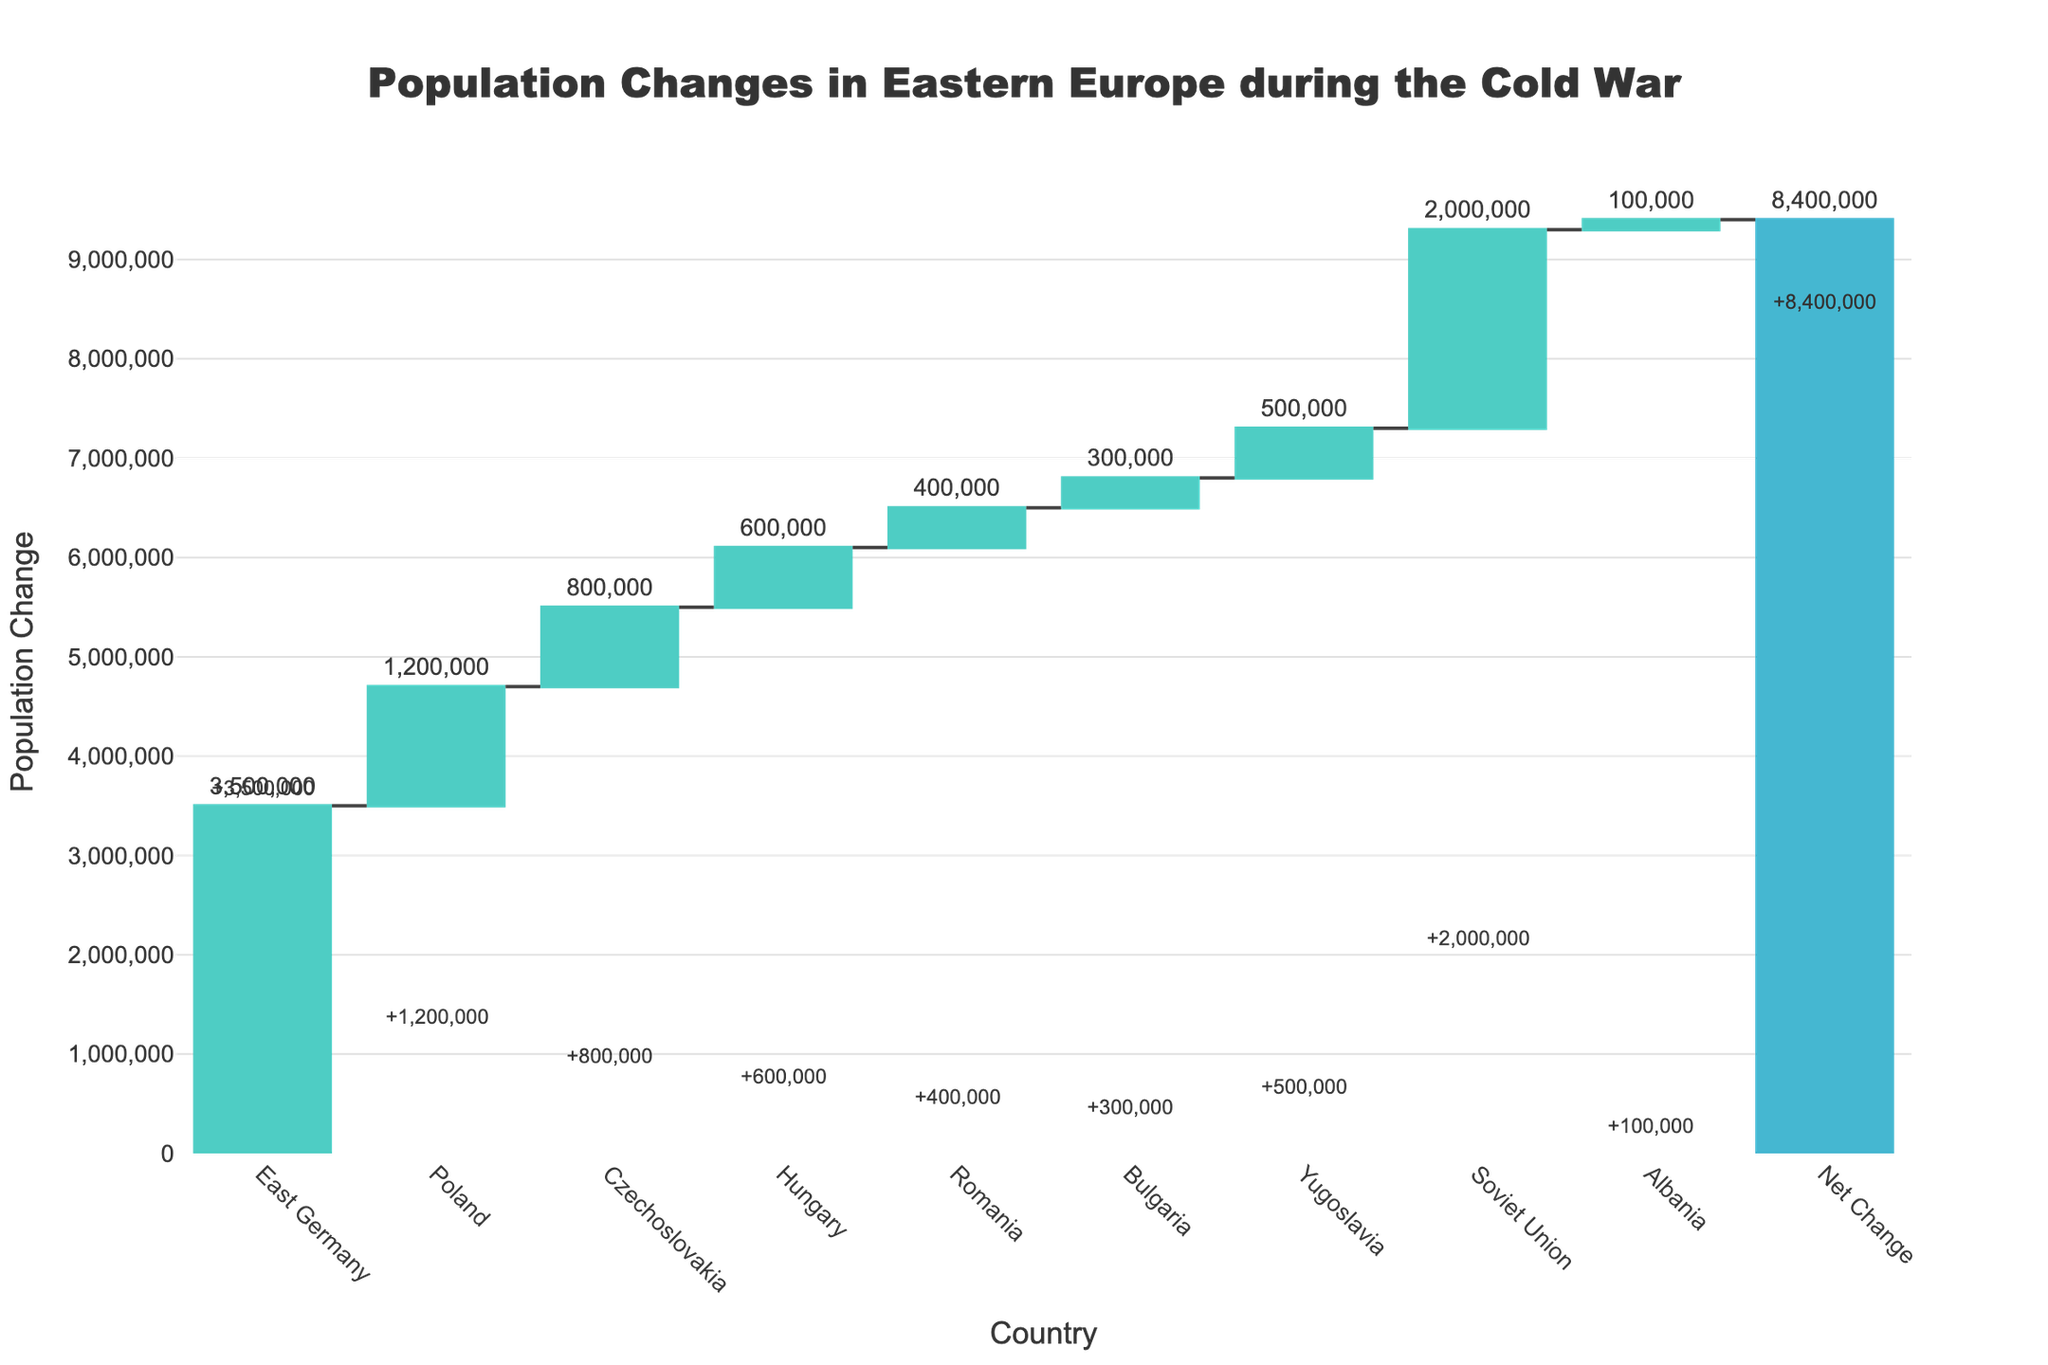What is the title of the chart? The title is located at the top of the chart and reads "Population Changes in Eastern Europe during the Cold War".
Answer: "Population Changes in Eastern Europe during the Cold War" Which country experienced the largest population decrease? Looking at the chart, the largest decline in population is represented by the bar for East Germany, which has the farthest downward extent.
Answer: East Germany What is the total net change in population? The net change in population is shown as the last bar in the chart, labeled "Net Change," which sums all the increases and decreases. It shows -8,400,000.
Answer: -8,400,000 How does the population change in Yugoslavia compare to other countries? Yugoslavia is the only country with an upward bar, indicating a population increase, while all other countries have downward bars indicating decreases.
Answer: Only increase What was the population change in Poland? The bar for Poland goes downward, indicating a population decrease of 1,200,000, as highlighted by the text next to the bar.
Answer: -1,200,000 Which countries had a population decrease of more than one million? By observing the bars and their respective labels, East Germany, Poland, and the Soviet Union had population decreases greater than one million.
Answer: East Germany, Poland, Soviet Union What is the average population decrease among all the countries listed excluding the net change? Add the absolute values of all the population changes excluding the net change (3,500,000 + 1,200,000 + 800,000 + 600,000 + 400,000 + 300,000 + 2,000,000 + 100,000) and divide by 8. The average is (8,900,000/8).
Answer: 1,112,500 How does the population change in the Soviet Union compare to Czechoslovakia? The Soviet Union's decrease of 2,000,000 is larger than Czechoslovakia's decrease of 800,000.
Answer: Larger What color is used to represent an increase in population change? The bars that represent increases are colored in green, as seen for Yugoslavia.
Answer: Green Which countries experienced a population decrease between 300,000 and 800,000? Look at the labels: Czechoslovakia (800,000), Hungary (600,000), Romania (400,000), and Bulgaria (300,000) fall within this range.
Answer: Czechoslovakia, Hungary, Romania, Bulgaria 